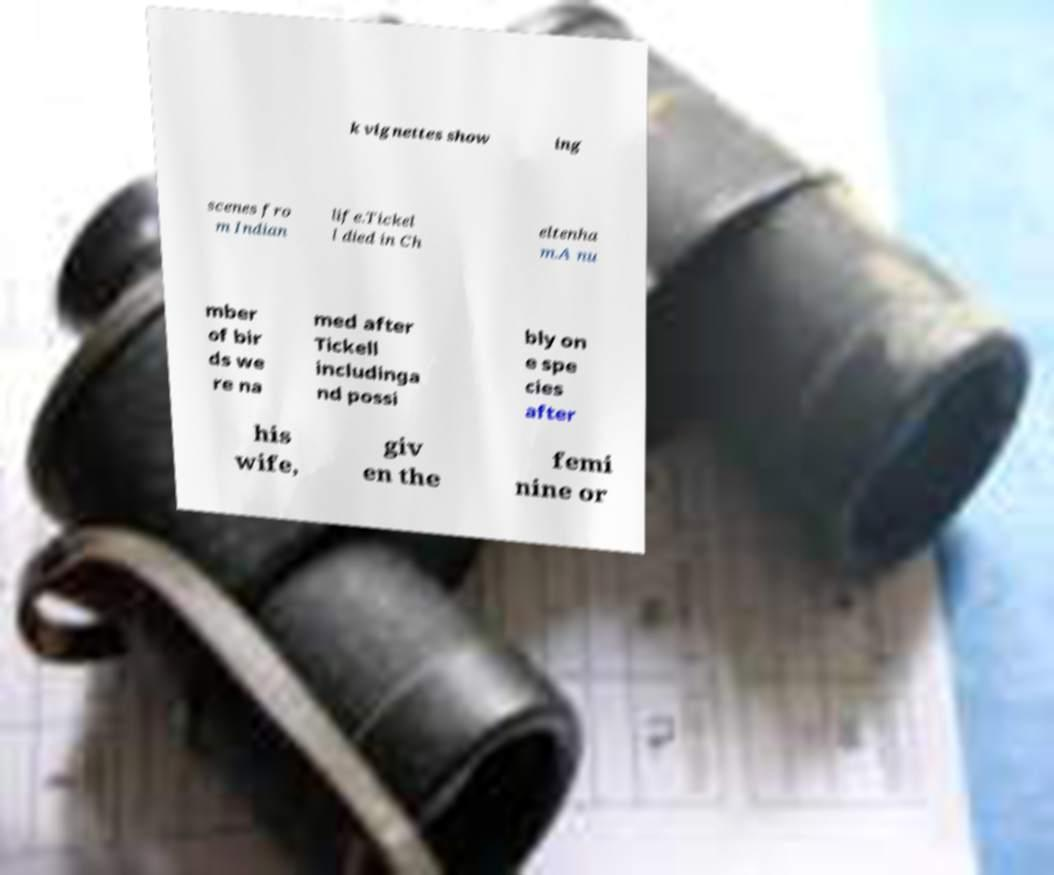Can you accurately transcribe the text from the provided image for me? k vignettes show ing scenes fro m Indian life.Tickel l died in Ch eltenha m.A nu mber of bir ds we re na med after Tickell includinga nd possi bly on e spe cies after his wife, giv en the femi nine or 